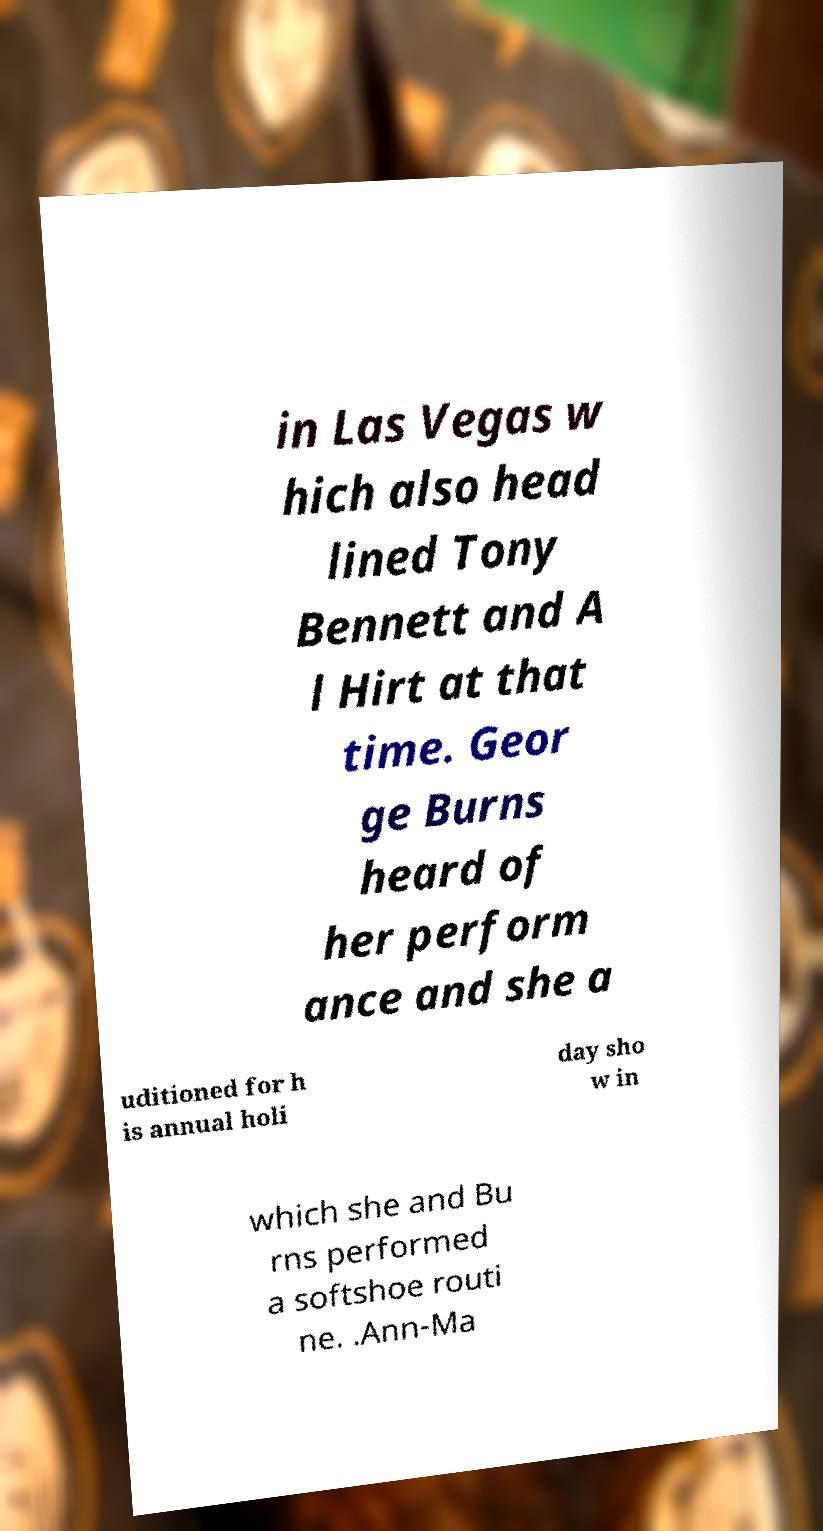Could you assist in decoding the text presented in this image and type it out clearly? in Las Vegas w hich also head lined Tony Bennett and A l Hirt at that time. Geor ge Burns heard of her perform ance and she a uditioned for h is annual holi day sho w in which she and Bu rns performed a softshoe routi ne. .Ann-Ma 